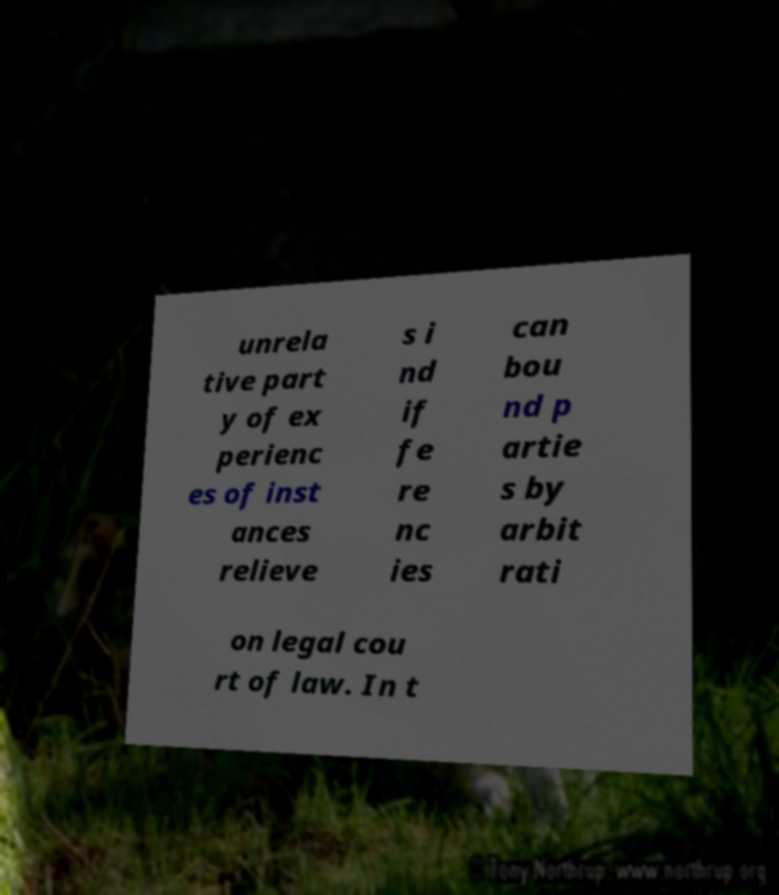Please read and relay the text visible in this image. What does it say? unrela tive part y of ex perienc es of inst ances relieve s i nd if fe re nc ies can bou nd p artie s by arbit rati on legal cou rt of law. In t 